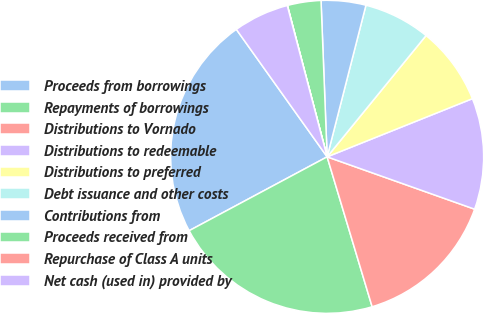<chart> <loc_0><loc_0><loc_500><loc_500><pie_chart><fcel>Proceeds from borrowings<fcel>Repayments of borrowings<fcel>Distributions to Vornado<fcel>Distributions to redeemable<fcel>Distributions to preferred<fcel>Debt issuance and other costs<fcel>Contributions from<fcel>Proceeds received from<fcel>Repurchase of Class A units<fcel>Net cash (used in) provided by<nl><fcel>22.97%<fcel>21.82%<fcel>14.93%<fcel>11.49%<fcel>8.05%<fcel>6.9%<fcel>4.61%<fcel>3.46%<fcel>0.02%<fcel>5.75%<nl></chart> 